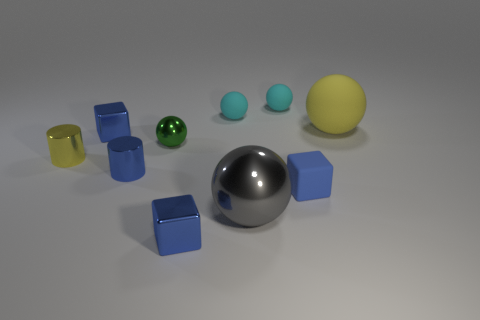There is another small object that is the same shape as the tiny yellow metal object; what material is it?
Ensure brevity in your answer.  Metal. There is a tiny block to the left of the tiny blue metallic block on the right side of the tiny blue cube that is behind the blue cylinder; what color is it?
Your answer should be compact. Blue. What number of objects are small blue matte cylinders or green metallic things?
Offer a very short reply. 1. How many big metal objects have the same shape as the large rubber object?
Give a very brief answer. 1. Do the tiny yellow thing and the large sphere in front of the big rubber object have the same material?
Offer a very short reply. Yes. What is the size of the yellow cylinder that is made of the same material as the small blue cylinder?
Your answer should be compact. Small. There is a metallic cube that is to the right of the green sphere; what is its size?
Your answer should be compact. Small. How many red things have the same size as the blue matte thing?
Ensure brevity in your answer.  0. Is there a metallic block of the same color as the small rubber block?
Provide a short and direct response. Yes. What is the color of the shiny ball that is the same size as the blue rubber object?
Keep it short and to the point. Green. 